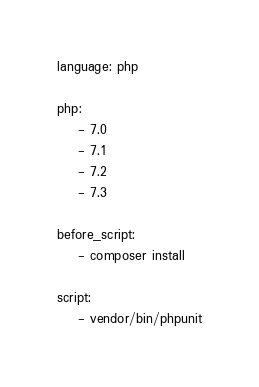<code> <loc_0><loc_0><loc_500><loc_500><_YAML_>language: php

php:
    - 7.0
    - 7.1
    - 7.2
    - 7.3

before_script:
    - composer install

script:
    - vendor/bin/phpunit
</code> 